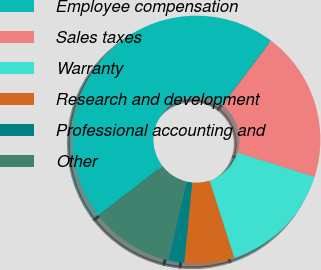<chart> <loc_0><loc_0><loc_500><loc_500><pie_chart><fcel>Employee compensation<fcel>Sales taxes<fcel>Warranty<fcel>Research and development<fcel>Professional accounting and<fcel>Other<nl><fcel>45.78%<fcel>19.58%<fcel>15.21%<fcel>6.48%<fcel>2.11%<fcel>10.84%<nl></chart> 